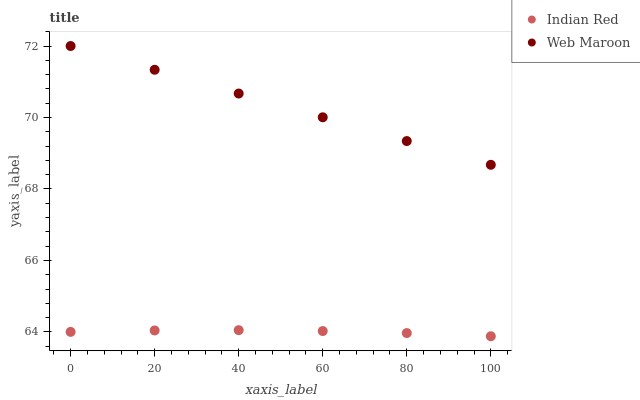Does Indian Red have the minimum area under the curve?
Answer yes or no. Yes. Does Web Maroon have the maximum area under the curve?
Answer yes or no. Yes. Does Indian Red have the maximum area under the curve?
Answer yes or no. No. Is Web Maroon the smoothest?
Answer yes or no. Yes. Is Indian Red the roughest?
Answer yes or no. Yes. Is Indian Red the smoothest?
Answer yes or no. No. Does Indian Red have the lowest value?
Answer yes or no. Yes. Does Web Maroon have the highest value?
Answer yes or no. Yes. Does Indian Red have the highest value?
Answer yes or no. No. Is Indian Red less than Web Maroon?
Answer yes or no. Yes. Is Web Maroon greater than Indian Red?
Answer yes or no. Yes. Does Indian Red intersect Web Maroon?
Answer yes or no. No. 